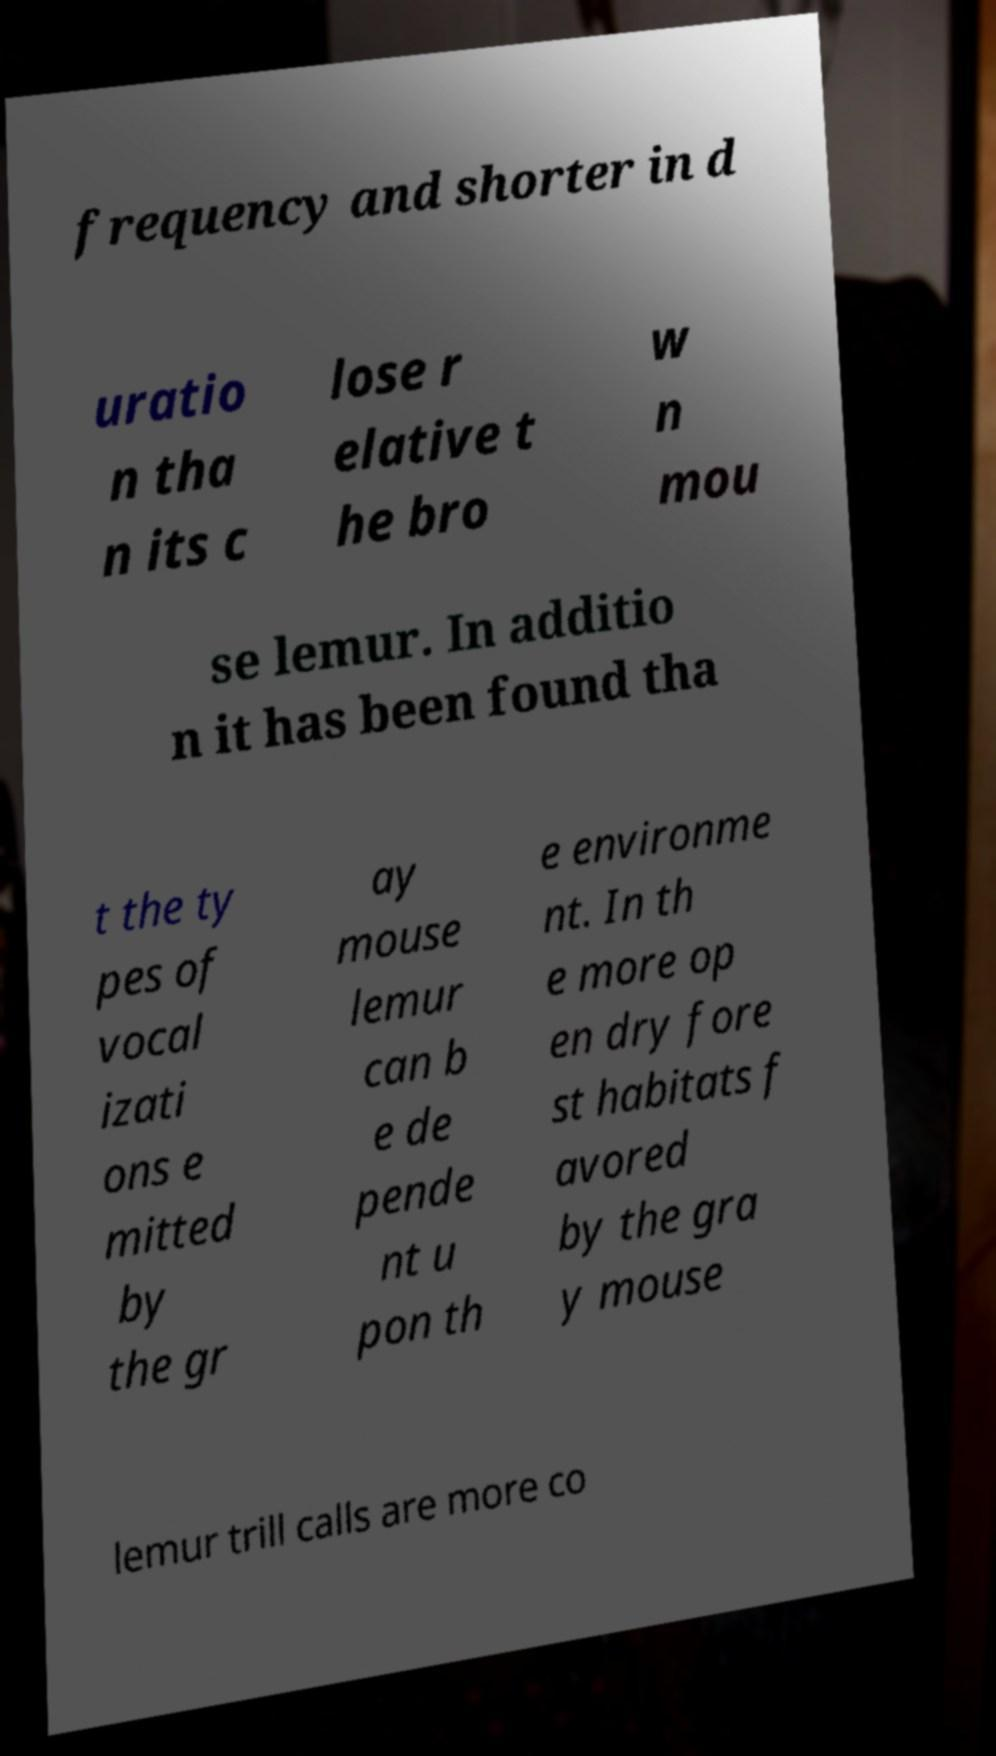I need the written content from this picture converted into text. Can you do that? frequency and shorter in d uratio n tha n its c lose r elative t he bro w n mou se lemur. In additio n it has been found tha t the ty pes of vocal izati ons e mitted by the gr ay mouse lemur can b e de pende nt u pon th e environme nt. In th e more op en dry fore st habitats f avored by the gra y mouse lemur trill calls are more co 